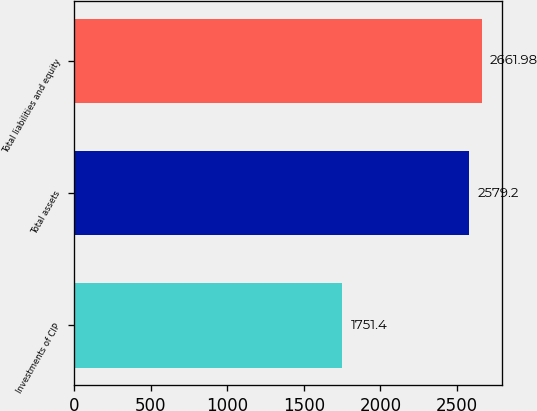Convert chart to OTSL. <chart><loc_0><loc_0><loc_500><loc_500><bar_chart><fcel>Investments of CIP<fcel>Total assets<fcel>Total liabilities and equity<nl><fcel>1751.4<fcel>2579.2<fcel>2661.98<nl></chart> 